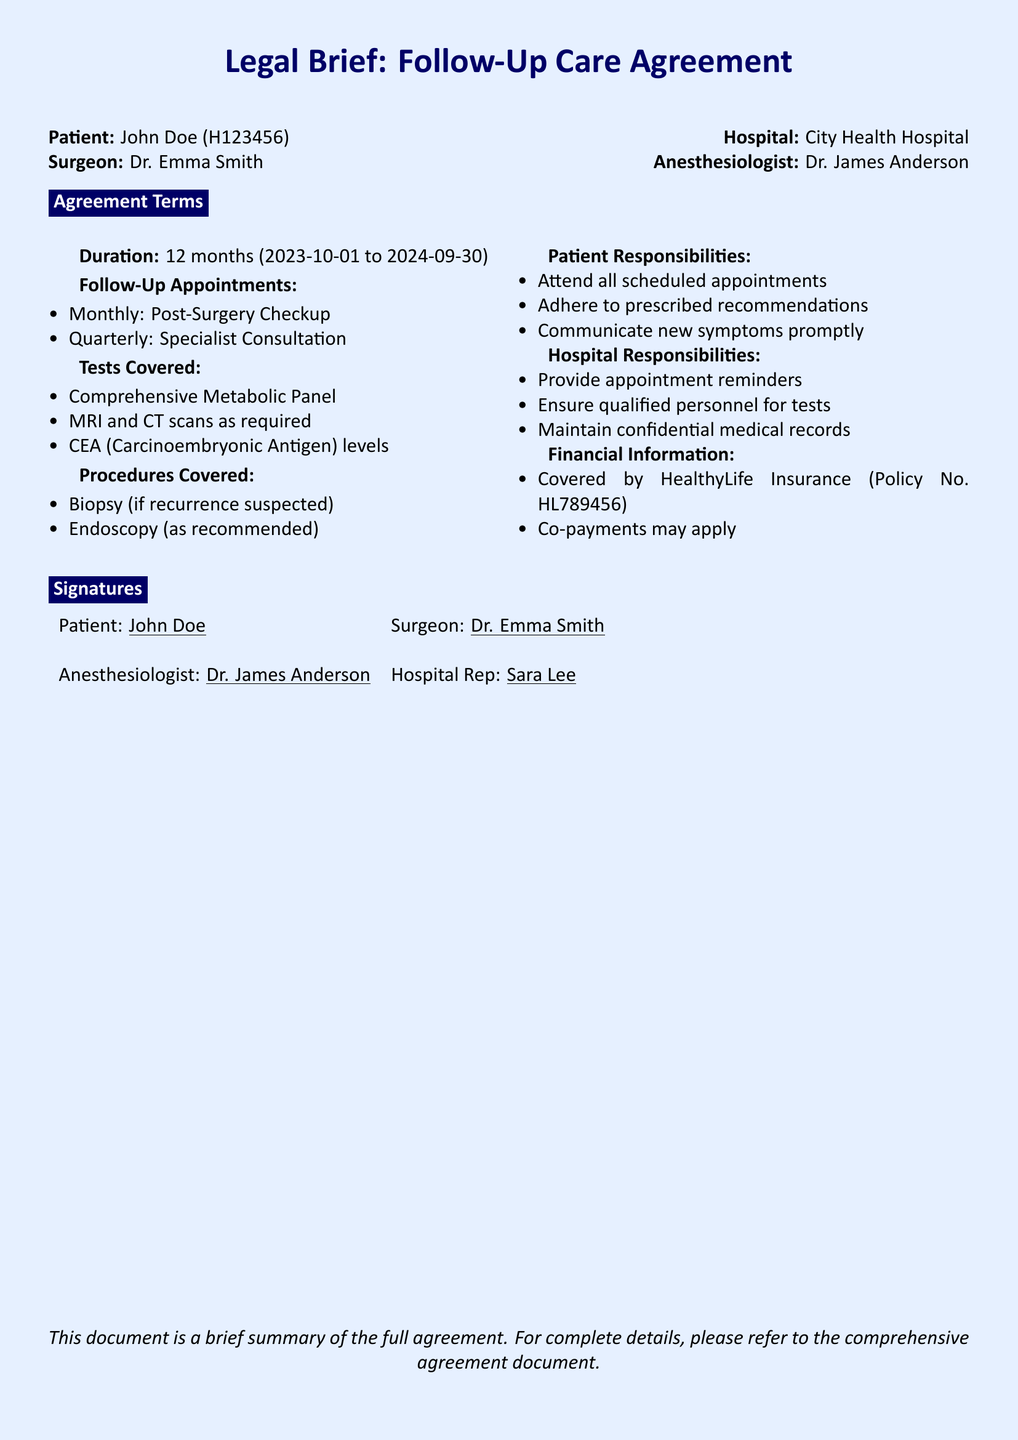What is the patient's name? The patient's name is explicitly stated in the document.
Answer: John Doe Who performed the surgery? The document mentions the surgeon's name directly.
Answer: Dr. Emma Smith What is the duration of the follow-up care agreement? The duration is provided as a specific time frame in the document.
Answer: 12 months How often are post-surgery checkups scheduled? The document specifies the frequency of appointments.
Answer: Monthly What tests are covered under the agreement? The document lists tests, and this one is an example given.
Answer: Comprehensive Metabolic Panel What is the patient responsible for? The document outlines various responsibilities of the patient.
Answer: Attend all scheduled appointments Who is the hospital representative? The document identifies a specific person representing the hospital.
Answer: Sara Lee What type of insurance is the follow-up care covered by? The document provides information about the insurance policy.
Answer: HealthyLife Insurance How many quarterly specialist consultations are included? The document states the appointment schedule, which includes types.
Answer: One What procedures are covered if a recurrence is suspected? The document describes procedures related to recurring conditions.
Answer: Biopsy 